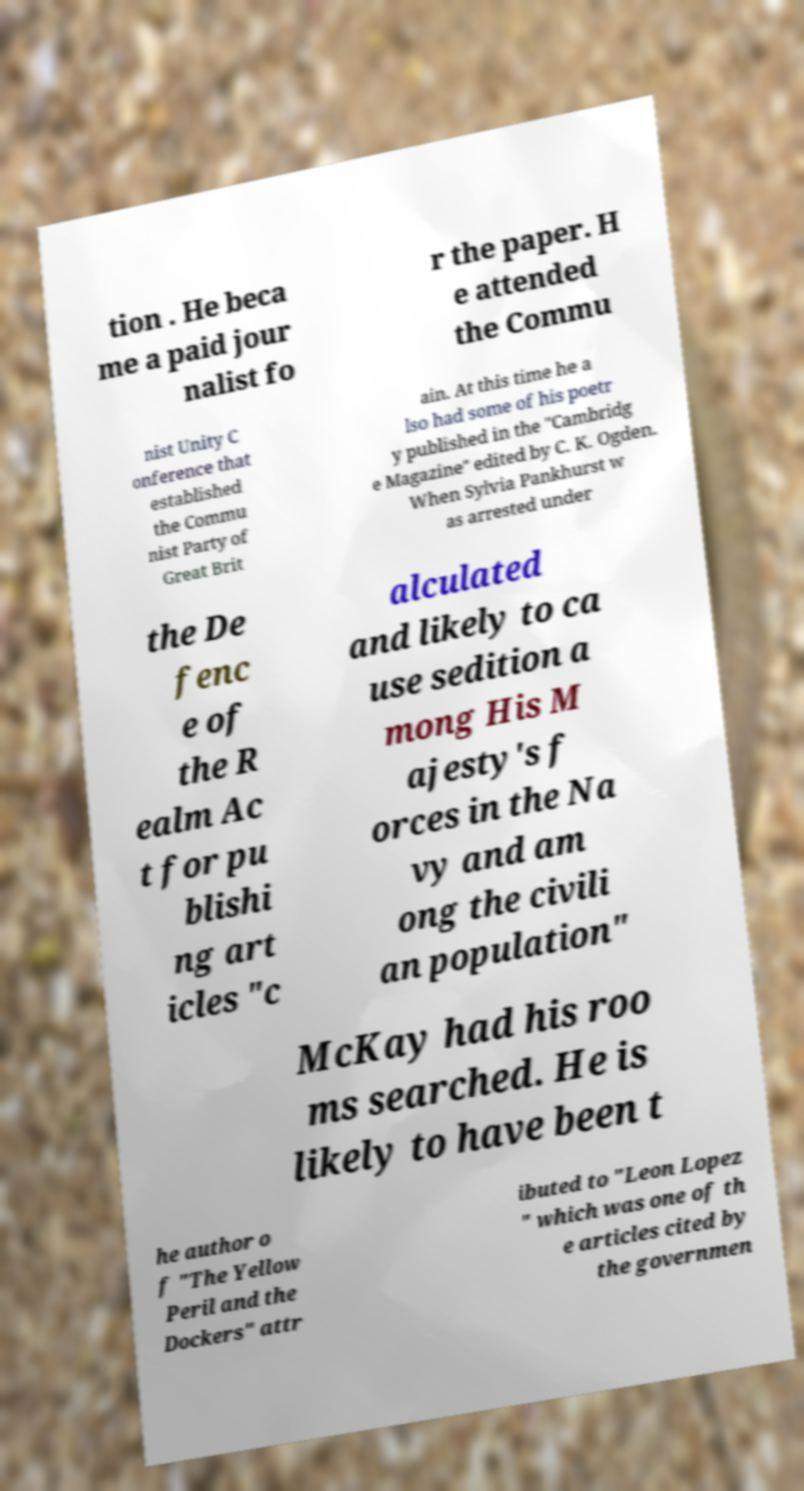Could you extract and type out the text from this image? tion . He beca me a paid jour nalist fo r the paper. H e attended the Commu nist Unity C onference that established the Commu nist Party of Great Brit ain. At this time he a lso had some of his poetr y published in the "Cambridg e Magazine" edited by C. K. Ogden. When Sylvia Pankhurst w as arrested under the De fenc e of the R ealm Ac t for pu blishi ng art icles "c alculated and likely to ca use sedition a mong His M ajesty's f orces in the Na vy and am ong the civili an population" McKay had his roo ms searched. He is likely to have been t he author o f "The Yellow Peril and the Dockers" attr ibuted to "Leon Lopez " which was one of th e articles cited by the governmen 